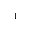<formula> <loc_0><loc_0><loc_500><loc_500>^ { - 1 }</formula> 